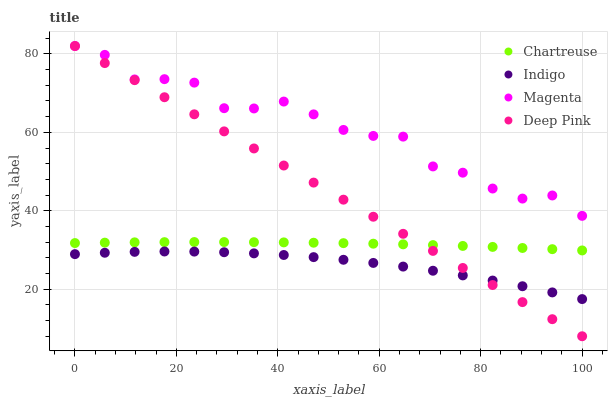Does Indigo have the minimum area under the curve?
Answer yes or no. Yes. Does Magenta have the maximum area under the curve?
Answer yes or no. Yes. Does Deep Pink have the minimum area under the curve?
Answer yes or no. No. Does Deep Pink have the maximum area under the curve?
Answer yes or no. No. Is Deep Pink the smoothest?
Answer yes or no. Yes. Is Magenta the roughest?
Answer yes or no. Yes. Is Indigo the smoothest?
Answer yes or no. No. Is Indigo the roughest?
Answer yes or no. No. Does Deep Pink have the lowest value?
Answer yes or no. Yes. Does Indigo have the lowest value?
Answer yes or no. No. Does Magenta have the highest value?
Answer yes or no. Yes. Does Indigo have the highest value?
Answer yes or no. No. Is Indigo less than Chartreuse?
Answer yes or no. Yes. Is Chartreuse greater than Indigo?
Answer yes or no. Yes. Does Deep Pink intersect Indigo?
Answer yes or no. Yes. Is Deep Pink less than Indigo?
Answer yes or no. No. Is Deep Pink greater than Indigo?
Answer yes or no. No. Does Indigo intersect Chartreuse?
Answer yes or no. No. 